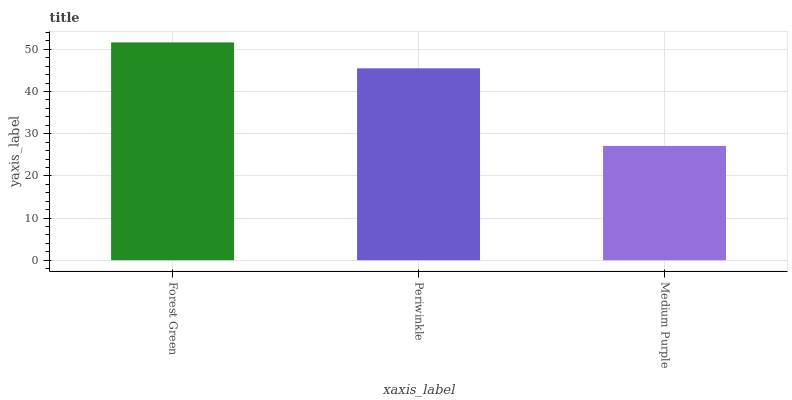Is Periwinkle the minimum?
Answer yes or no. No. Is Periwinkle the maximum?
Answer yes or no. No. Is Forest Green greater than Periwinkle?
Answer yes or no. Yes. Is Periwinkle less than Forest Green?
Answer yes or no. Yes. Is Periwinkle greater than Forest Green?
Answer yes or no. No. Is Forest Green less than Periwinkle?
Answer yes or no. No. Is Periwinkle the high median?
Answer yes or no. Yes. Is Periwinkle the low median?
Answer yes or no. Yes. Is Forest Green the high median?
Answer yes or no. No. Is Forest Green the low median?
Answer yes or no. No. 